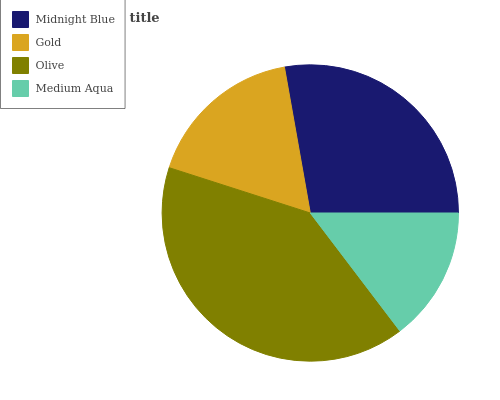Is Medium Aqua the minimum?
Answer yes or no. Yes. Is Olive the maximum?
Answer yes or no. Yes. Is Gold the minimum?
Answer yes or no. No. Is Gold the maximum?
Answer yes or no. No. Is Midnight Blue greater than Gold?
Answer yes or no. Yes. Is Gold less than Midnight Blue?
Answer yes or no. Yes. Is Gold greater than Midnight Blue?
Answer yes or no. No. Is Midnight Blue less than Gold?
Answer yes or no. No. Is Midnight Blue the high median?
Answer yes or no. Yes. Is Gold the low median?
Answer yes or no. Yes. Is Medium Aqua the high median?
Answer yes or no. No. Is Medium Aqua the low median?
Answer yes or no. No. 